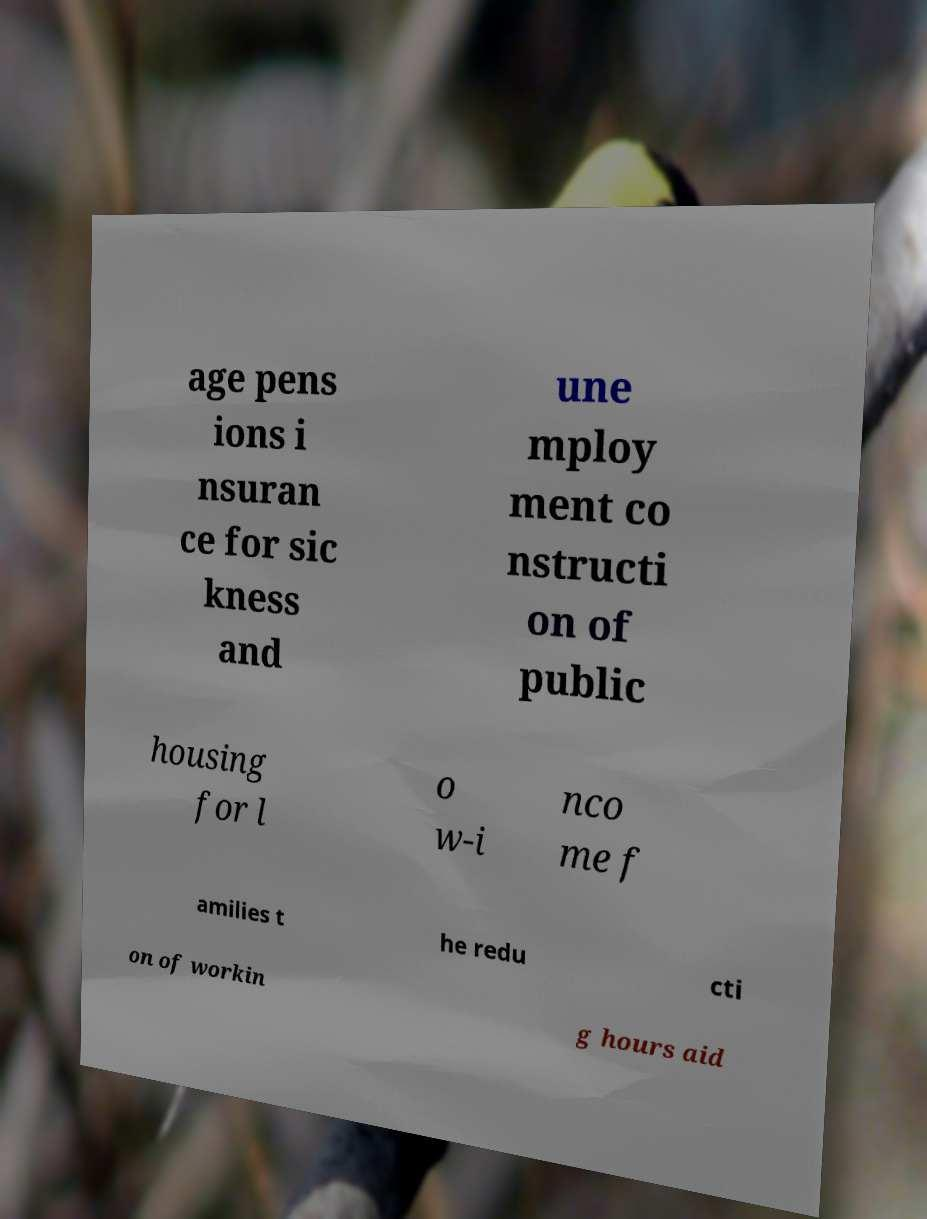For documentation purposes, I need the text within this image transcribed. Could you provide that? age pens ions i nsuran ce for sic kness and une mploy ment co nstructi on of public housing for l o w-i nco me f amilies t he redu cti on of workin g hours aid 